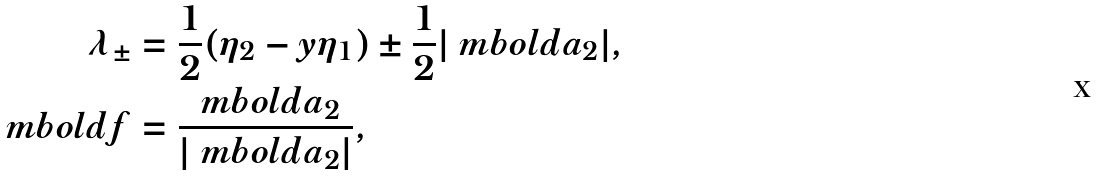Convert formula to latex. <formula><loc_0><loc_0><loc_500><loc_500>\lambda _ { \pm } & = \frac { 1 } { 2 } ( \eta _ { 2 } - y \eta _ { 1 } ) \pm \frac { 1 } { 2 } | \ m b o l d { a } _ { 2 } | , \\ \ m b o l d { f } & = \frac { \ m b o l d { a } _ { 2 } } { | \ m b o l d { a } _ { 2 } | } ,</formula> 